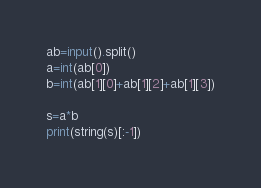Convert code to text. <code><loc_0><loc_0><loc_500><loc_500><_Python_>ab=input().split()
a=int(ab[0])
b=int(ab[1][0]+ab[1][2]+ab[1][3])
 
s=a*b
print(string(s)[:-1])</code> 